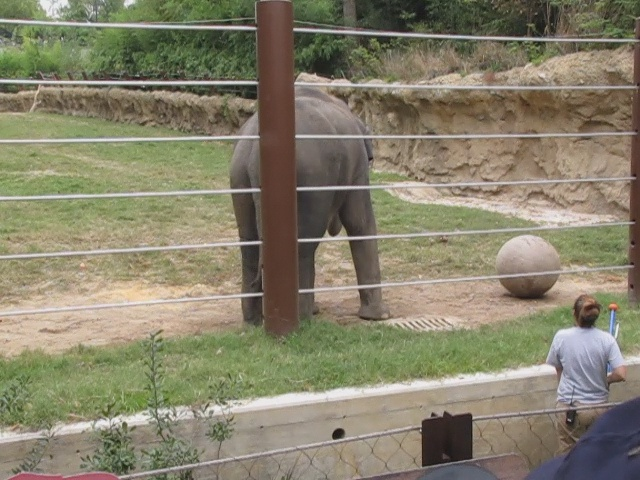Describe the objects in this image and their specific colors. I can see elephant in olive, gray, maroon, and black tones, people in olive, darkgray, gray, and lavender tones, sports ball in olive, darkgray, gray, and lightgray tones, and cell phone in olive, black, gray, and darkgray tones in this image. 